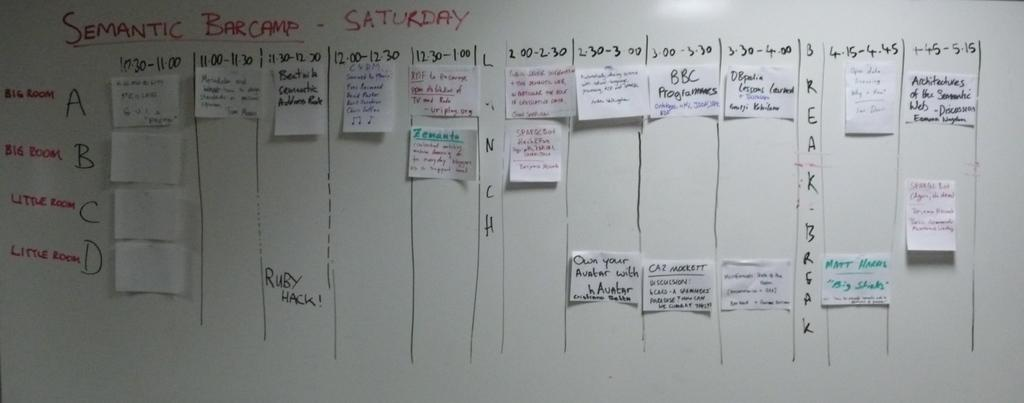Provide a one-sentence caption for the provided image. A dry erase board with writings titled Semantic Bar camp. 